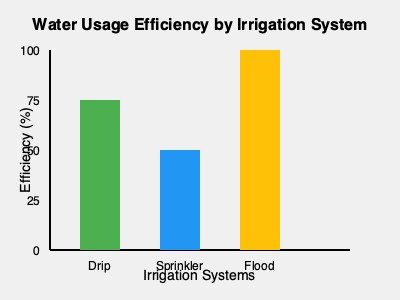Based on the graph, which irrigation system is most efficient for water usage, and by what percentage is it more efficient than the least efficient system? To solve this problem, we need to follow these steps:

1. Identify the most efficient irrigation system:
   - Drip irrigation: ~75% efficient
   - Sprinkler irrigation: ~50% efficient
   - Flood irrigation: ~80% efficient
   Flood irrigation is the most efficient system.

2. Identify the least efficient irrigation system:
   Sprinkler irrigation is the least efficient at ~50%.

3. Calculate the difference in efficiency:
   $\text{Difference} = \text{Flood efficiency} - \text{Sprinkler efficiency}$
   $\text{Difference} = 80\% - 50\% = 30\%$

4. Calculate the percentage increase:
   $\text{Percentage increase} = \frac{\text{Difference}}{\text{Sprinkler efficiency}} \times 100\%$
   $\text{Percentage increase} = \frac{30\%}{50\%} \times 100\% = 60\%$

Therefore, the flood irrigation system is 60% more efficient than the least efficient system (sprinkler irrigation).
Answer: Flood irrigation; 60% 